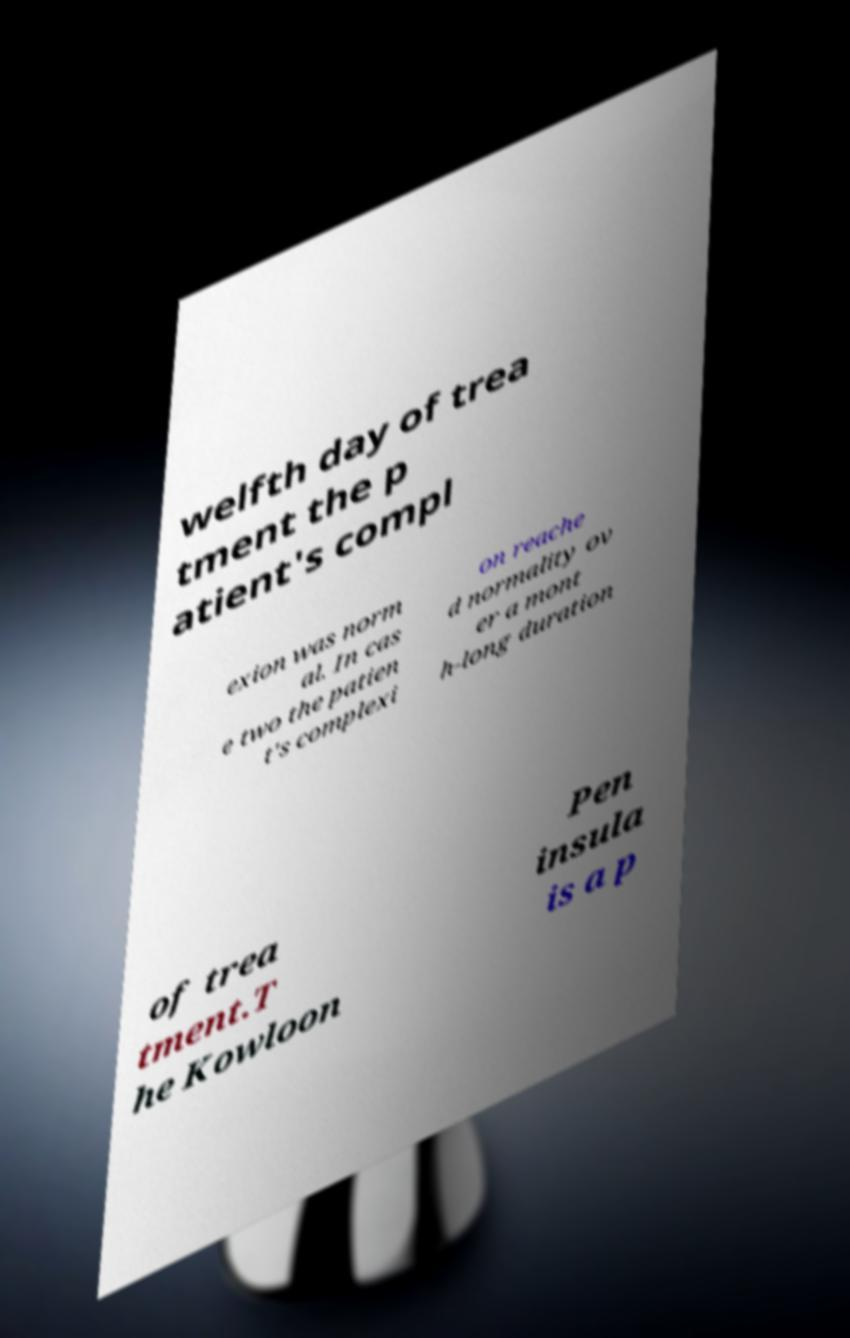What messages or text are displayed in this image? I need them in a readable, typed format. welfth day of trea tment the p atient's compl exion was norm al. In cas e two the patien t's complexi on reache d normality ov er a mont h-long duration of trea tment.T he Kowloon Pen insula is a p 